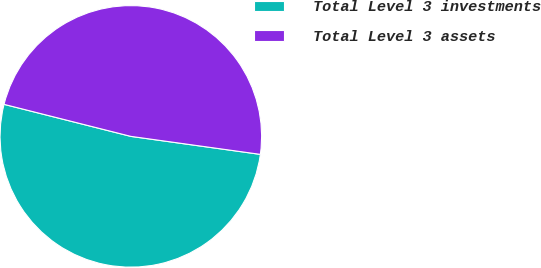Convert chart to OTSL. <chart><loc_0><loc_0><loc_500><loc_500><pie_chart><fcel>Total Level 3 investments<fcel>Total Level 3 assets<nl><fcel>51.74%<fcel>48.26%<nl></chart> 